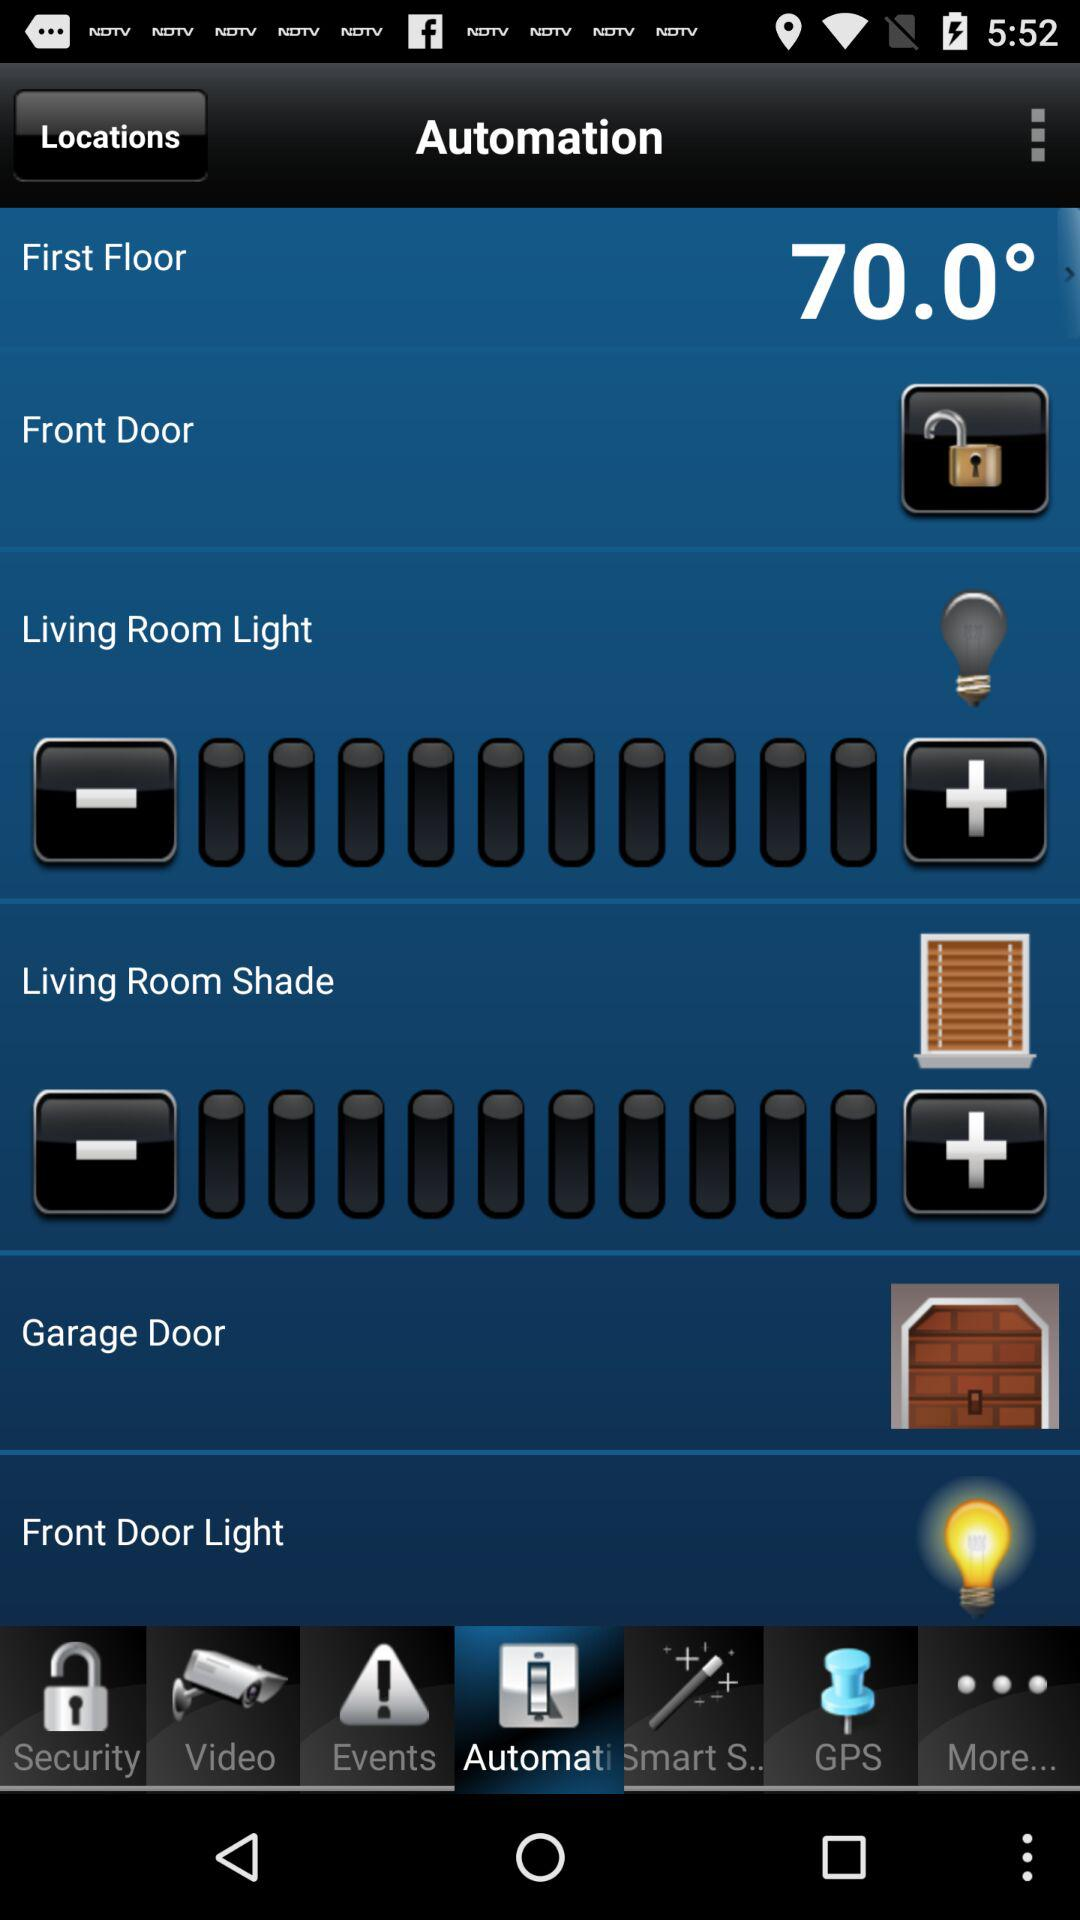Which tab am I using? You are using the "Automation" tab. 